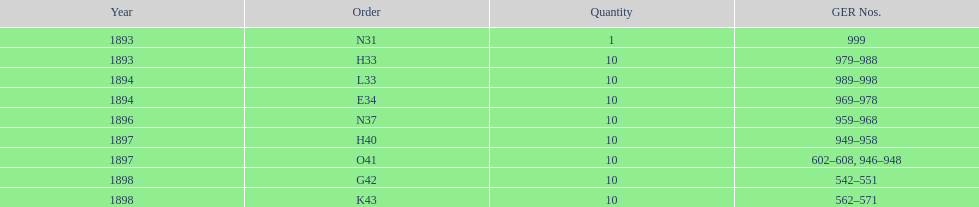Between n31 and e34, which one was ordered more? E34. 